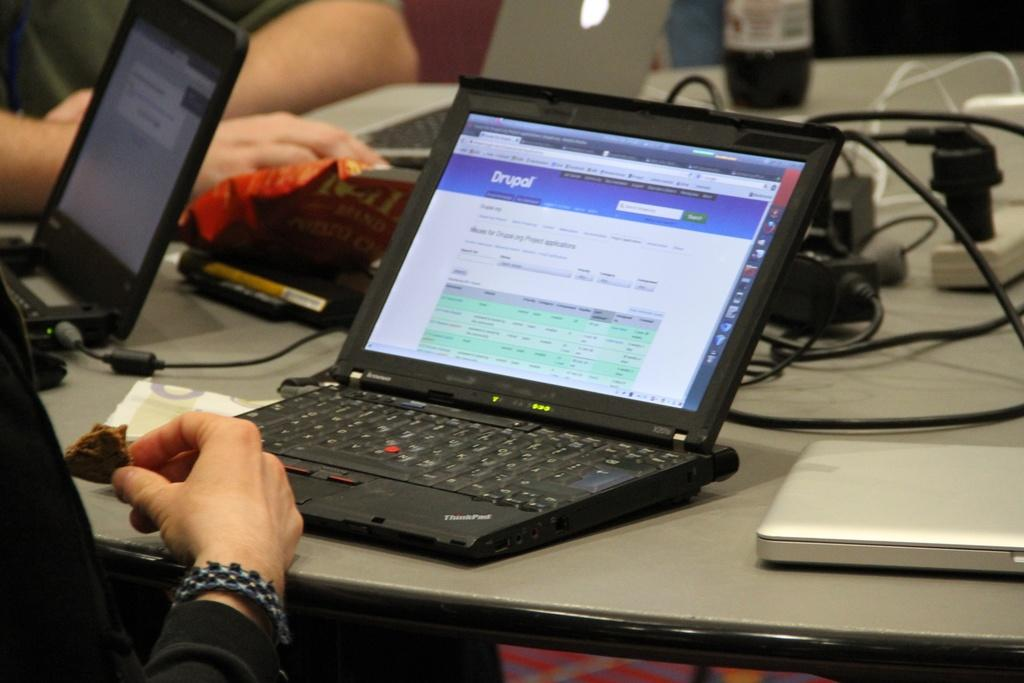Provide a one-sentence caption for the provided image. a black lap top computer open to a website named DRUPAL. 